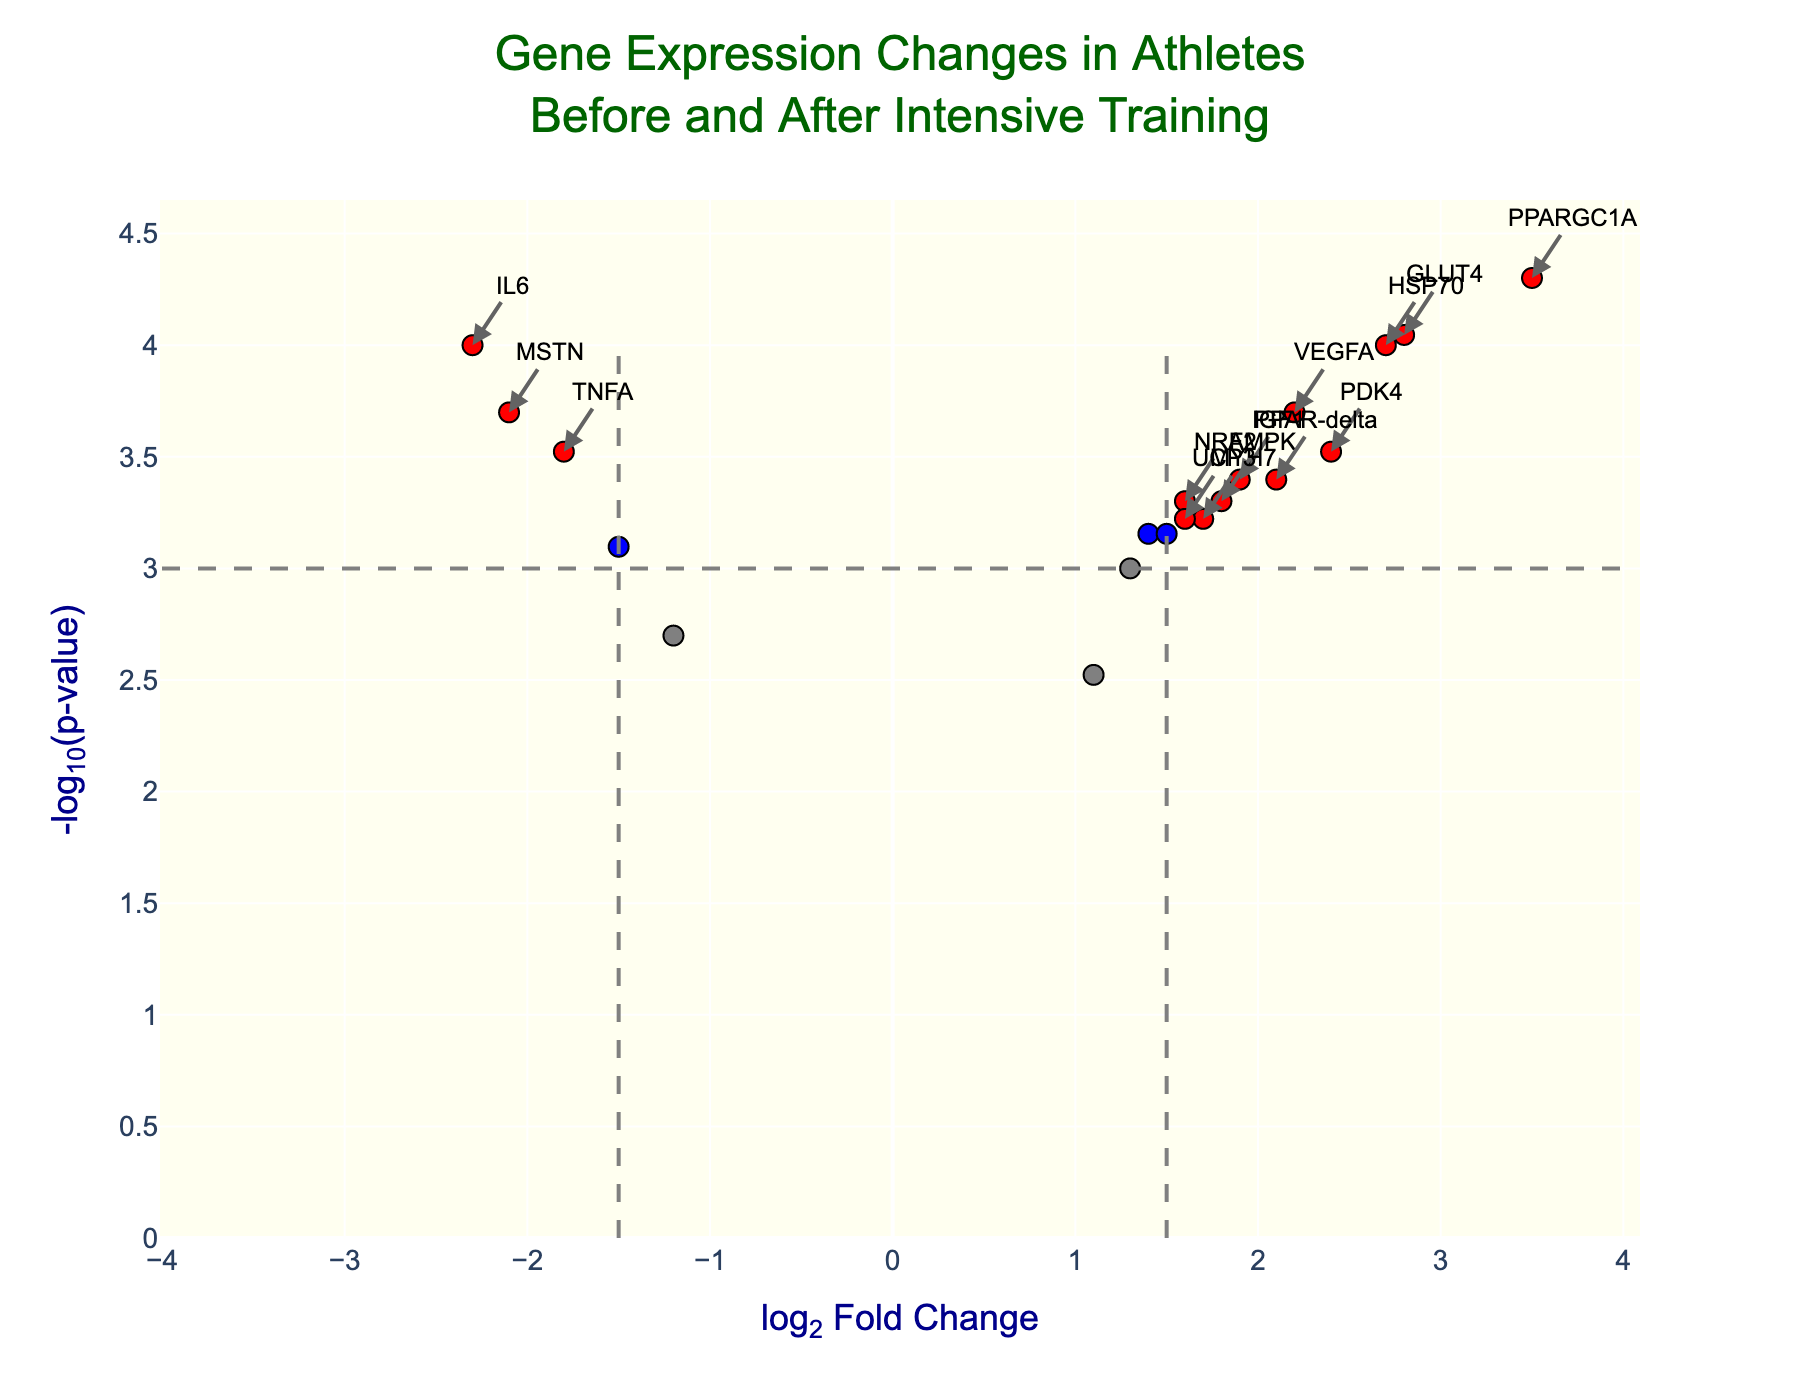What is the title of the figure? The title is usually located at the top of the figure and is clearly displayed. In this case, the title provided in the code is "Gene Expression Changes in Athletes Before and After Intensive Training."
Answer: Gene Expression Changes in Athletes Before and After Intensive Training Which gene has the highest log2FoldChange? To find the gene with the highest log2FoldChange, I would look for the point farthest to the right on the x-axis. From the data, PPARGC1A has the highest log2FoldChange of 3.5.
Answer: PPARGC1A Which gene has the lowest p-value? Since -log10(pvalue) transforms lower p-values into higher values on the y-axis, I would look for the point highest on the y-axis. According to the data, PPARGC1A has the lowest p-value of 0.00005.
Answer: PPARGC1A How many genes are significantly up-regulated? Significantly up-regulated genes are indicated by red points to the right of the log2FoldChange threshold line of 1.5 and above the p-value threshold line at -log10(pvalue). From the data, there are several genes in red on the right side: PPARGC1A, HSP70, GLUT4.
Answer: 3 What does the color red signify in the plot? According to the provided code, red indicates genes that are significantly up- or down-regulated with log2FoldChange greater than 1.5 or less than -1.5 and p-value less than 0.001.
Answer: Significantly up- or down-regulated genes Which gene has the highest -log10(pvalue) among the significantly down-regulated genes? By focusing on the points colored red on the left side of the x-axis and picking the one highest on the y-axis, I find that IL6 has the highest -log10(pvalue) among the significantly down-regulated genes.
Answer: IL6 What is the log2FoldChange and p-value of the gene ACTN3? Since the hover text in the plot displays this information, we can refer to the data where ACTN3 has a log2FoldChange of -1.5 and a p-value of 0.0008.
Answer: log2FoldChange: -1.5, p-value: 0.0008 How many genes have a log2FoldChange between -1.5 and 1.5? We check the points within the range of -1.5 to 1.5 on the x-axis. According to the data, genes like TNFA, MYH7, FOXO3, TFAM, UCP3, AMPK, and CITED4 fit this range.
Answer: 7 Which gene is located at (2.8, approximately 4) in the plot? This question involves identifying the specific data point in the figure. According to the data for log2FoldChange of 2.8 and -log10(pvalue) near 4, GLUT4 is the gene.
Answer: GLUT4 What are the log2FoldChange values for the genes with p-values greater than 0.001? The data points with p-values greater than 0.001 are colored differently, specifically blue or gray. According to the data, the genes are FOXO3, MYH7, TFAM, MYF6, CITED4 with log2FoldChanges 1.3, 1.7, 1.5, -1.2, 1.1 respectively.
Answer: FOXO3: 1.3, MYH7: 1.7, TFAM: 1.5, MYF6: -1.2, CITED4: 1.1 